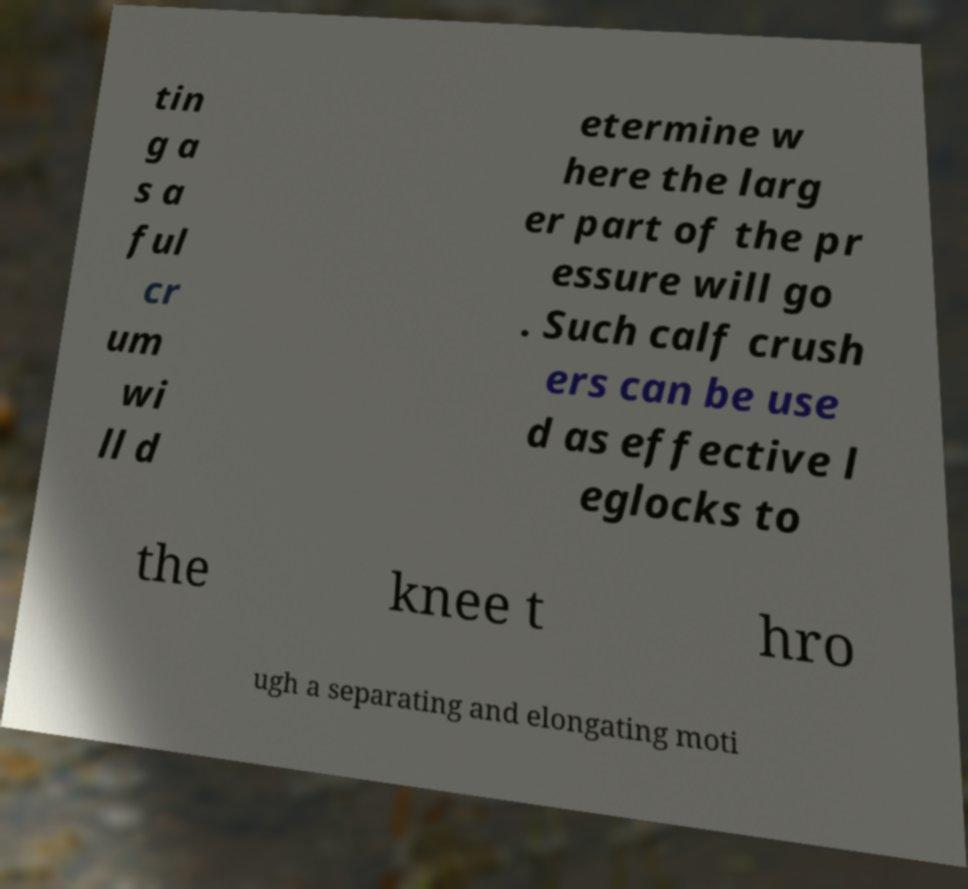Can you read and provide the text displayed in the image?This photo seems to have some interesting text. Can you extract and type it out for me? tin g a s a ful cr um wi ll d etermine w here the larg er part of the pr essure will go . Such calf crush ers can be use d as effective l eglocks to the knee t hro ugh a separating and elongating moti 